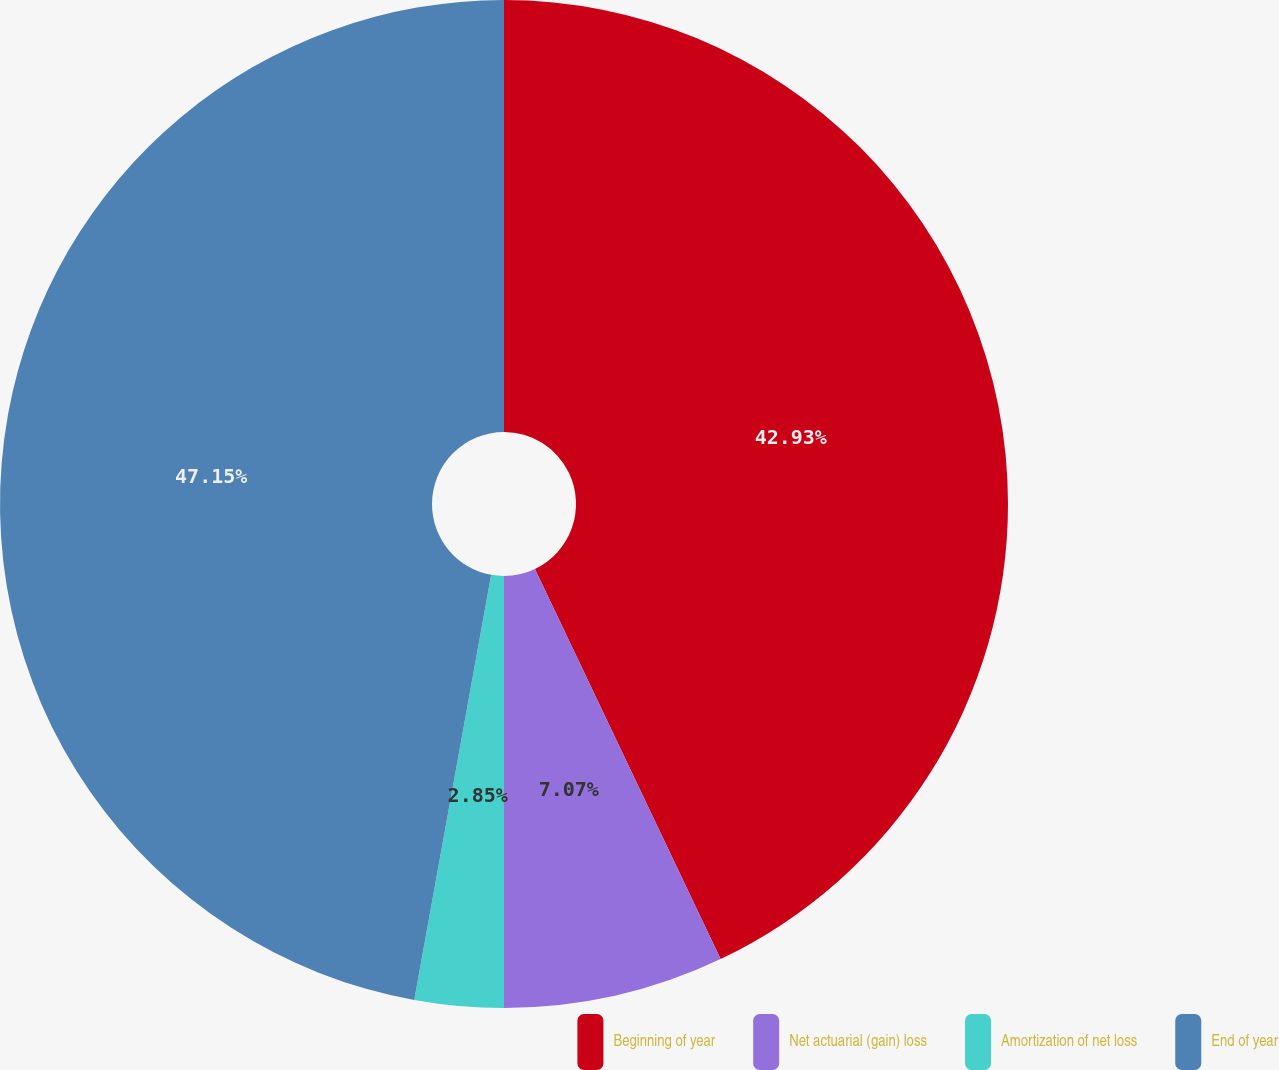Convert chart. <chart><loc_0><loc_0><loc_500><loc_500><pie_chart><fcel>Beginning of year<fcel>Net actuarial (gain) loss<fcel>Amortization of net loss<fcel>End of year<nl><fcel>42.93%<fcel>7.07%<fcel>2.85%<fcel>47.15%<nl></chart> 